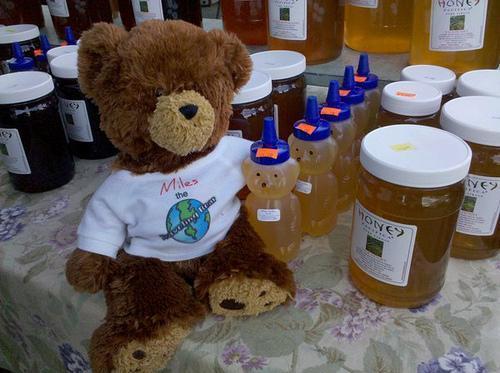How many teddy bears are there?
Give a very brief answer. 1. 